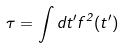<formula> <loc_0><loc_0><loc_500><loc_500>\tau = \int d t ^ { \prime } f ^ { 2 } ( t ^ { \prime } )</formula> 